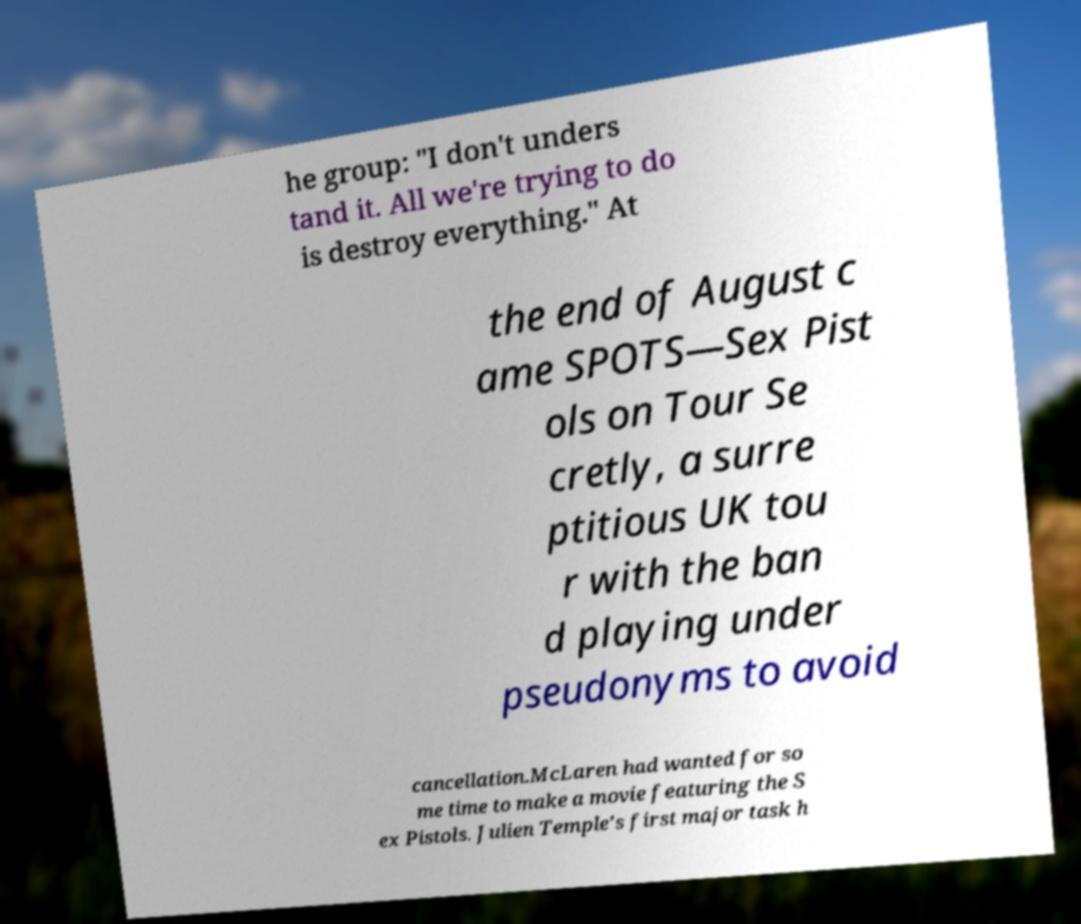For documentation purposes, I need the text within this image transcribed. Could you provide that? he group: "I don't unders tand it. All we're trying to do is destroy everything." At the end of August c ame SPOTS—Sex Pist ols on Tour Se cretly, a surre ptitious UK tou r with the ban d playing under pseudonyms to avoid cancellation.McLaren had wanted for so me time to make a movie featuring the S ex Pistols. Julien Temple's first major task h 